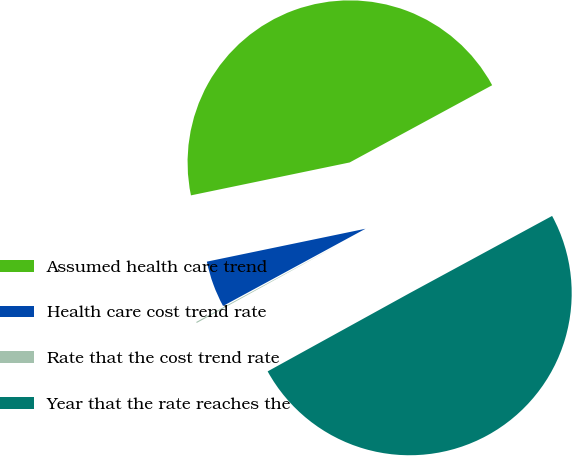<chart> <loc_0><loc_0><loc_500><loc_500><pie_chart><fcel>Assumed health care trend<fcel>Health care cost trend rate<fcel>Rate that the cost trend rate<fcel>Year that the rate reaches the<nl><fcel>45.35%<fcel>4.65%<fcel>0.11%<fcel>49.89%<nl></chart> 